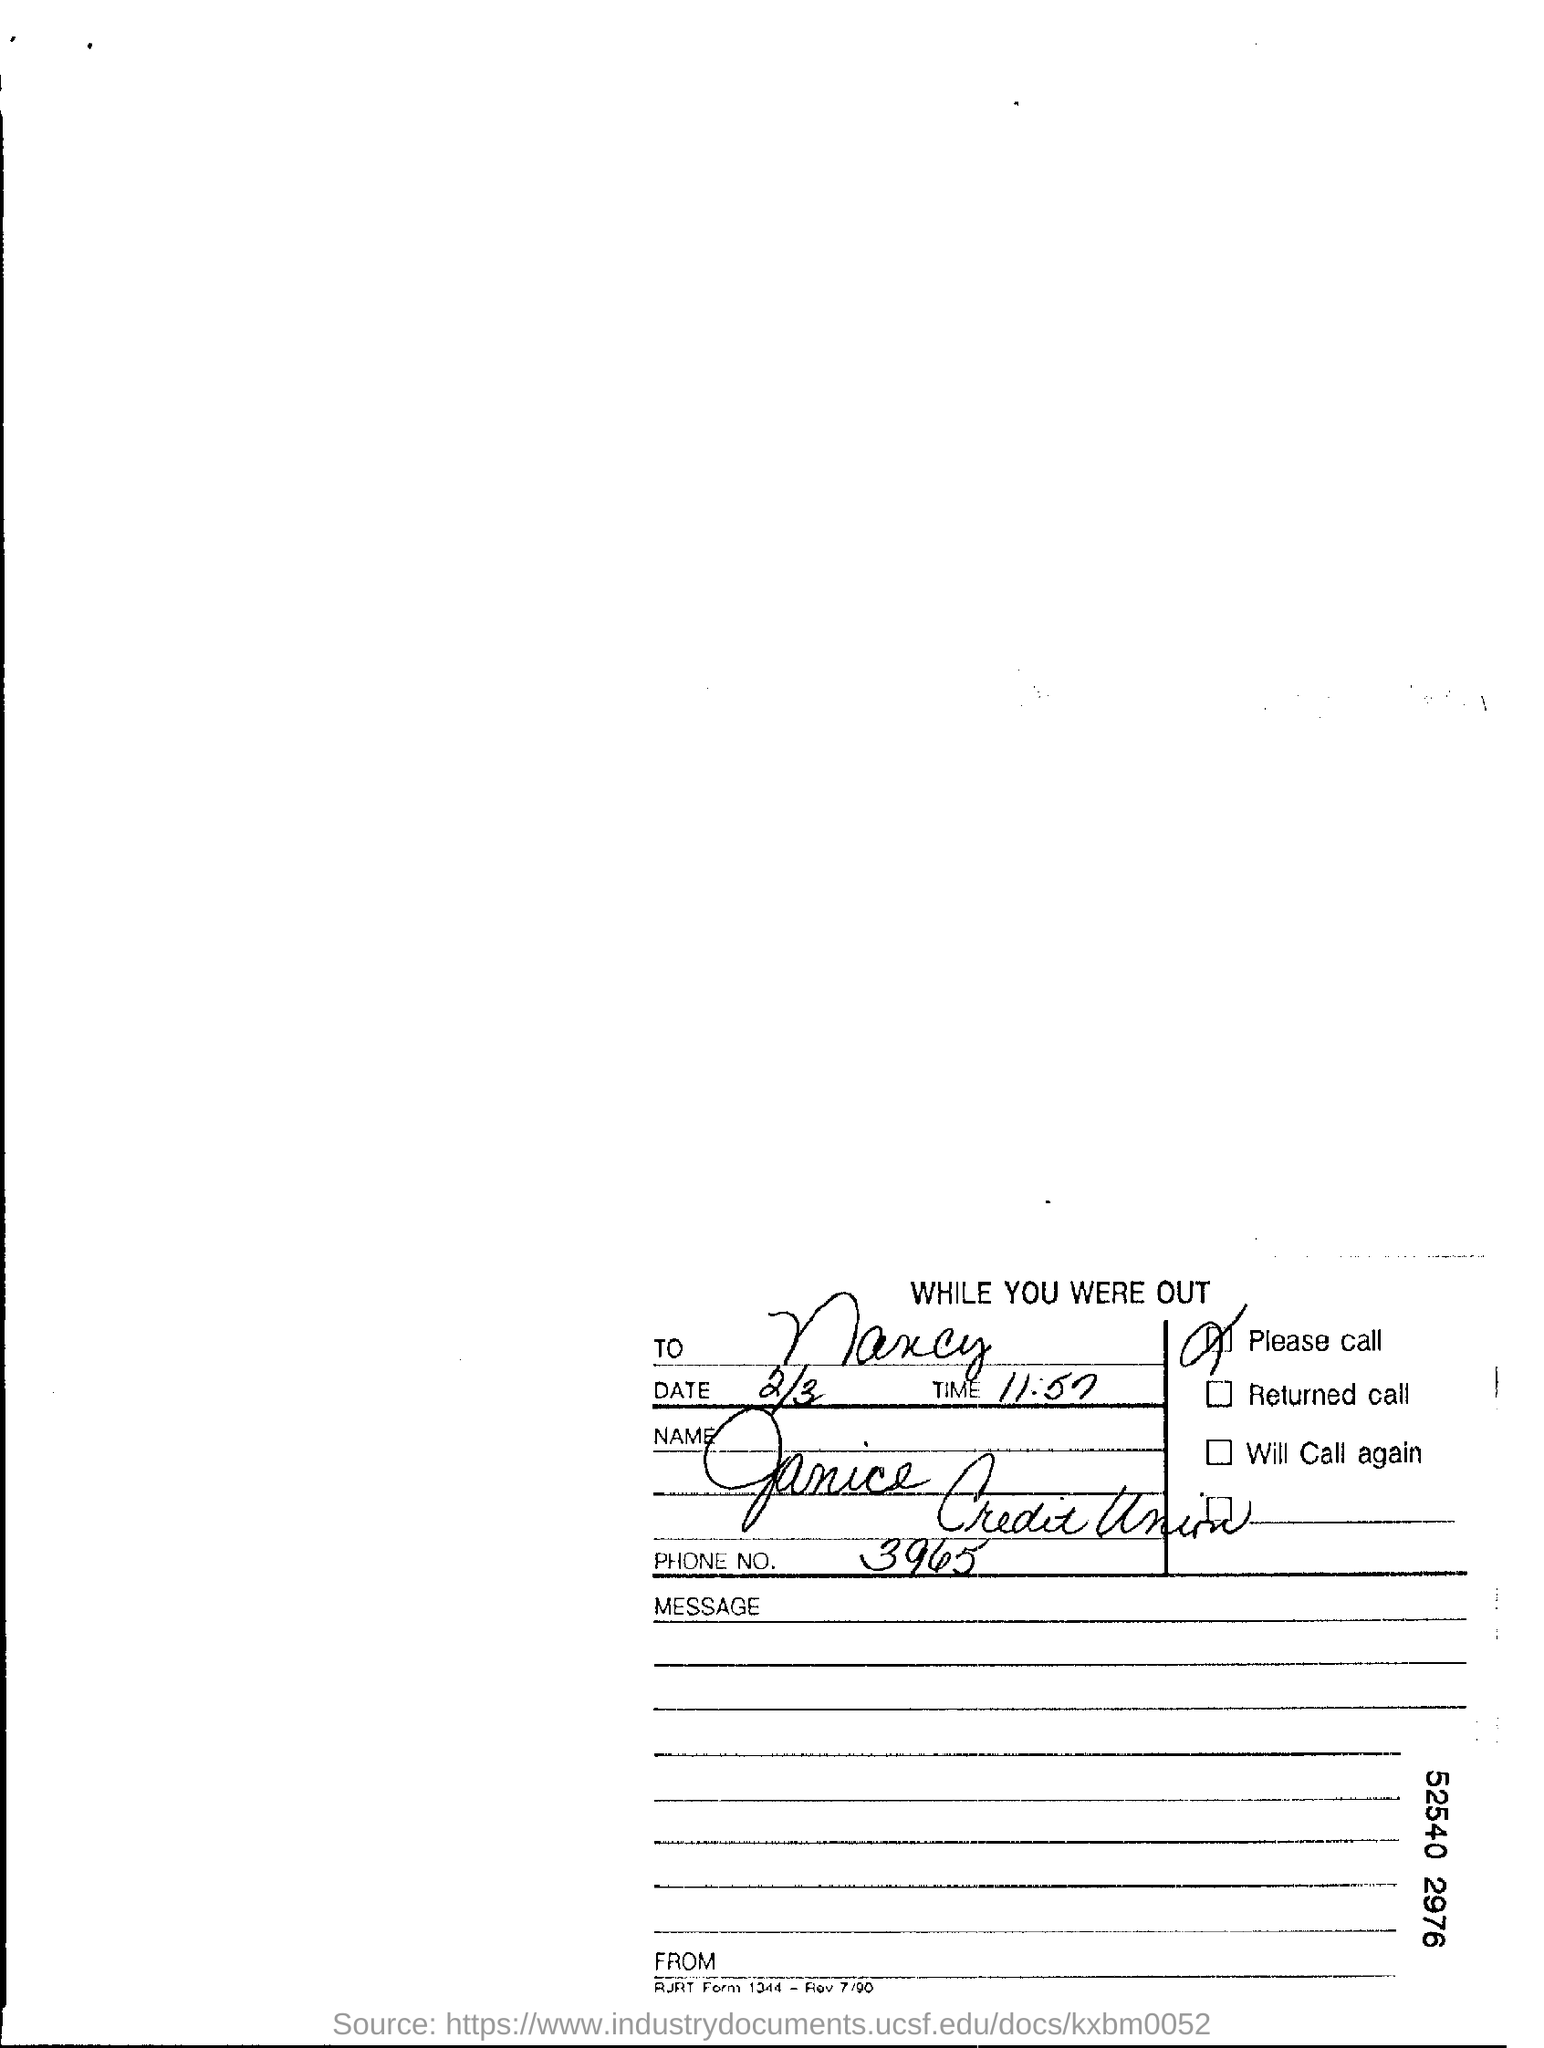To Whom is this addressed to?
Keep it short and to the point. Nancy. What is the Date?
Your response must be concise. 2/3. What is the Time?
Provide a short and direct response. 11:57. What is the Phone No.?
Make the answer very short. 3965. 